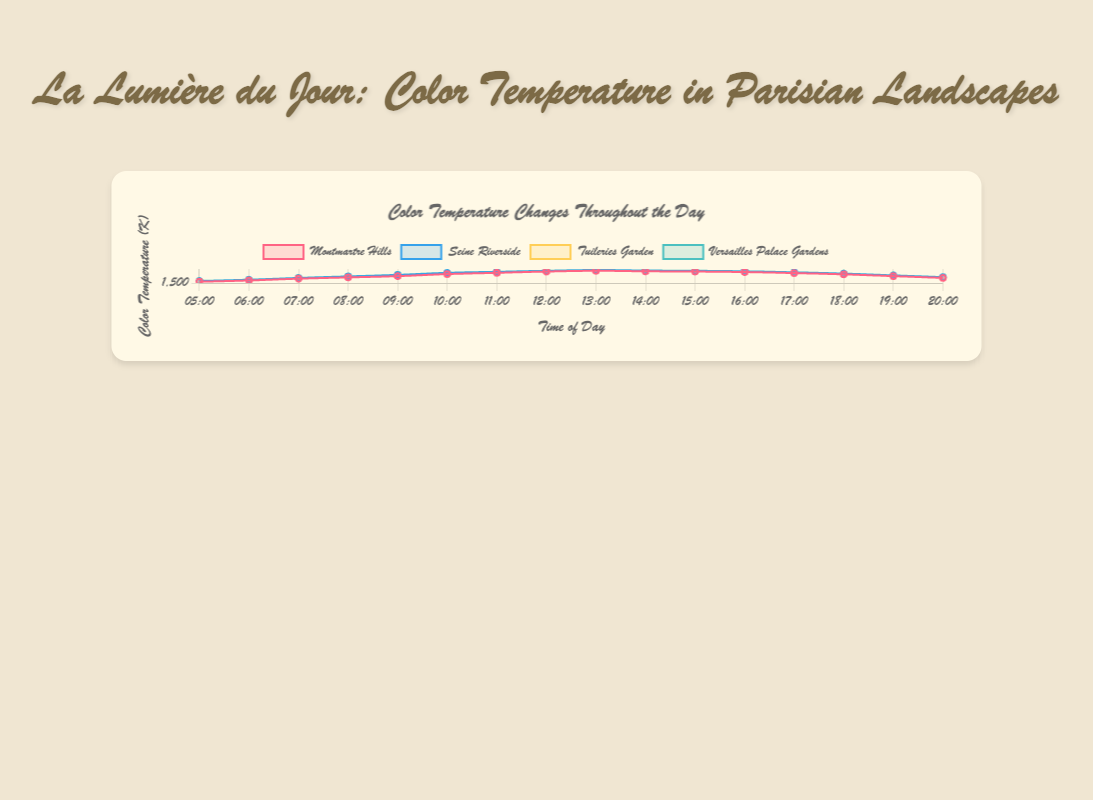What's the highest color temperature recorded in Montmartre Hills? To find the highest color temperature for Montmartre Hills, look at the temperature values across all times. The highest value recorded is 6300K at 13:00.
Answer: 6300K How does the color temperature in Seine Riverside at 10:00 compare to that in Tuileries Garden at the same time? Compare the color temperatures of Seine Riverside and Tuileries Garden at 10:00. For Seine Riverside, the temperature at 10:00 is 5400K, and for Tuileries Garden, it’s 5300K. Seine Riverside’s temperature is slightly higher.
Answer: Seine Riverside is higher What is the average color temperature in Versailles Palace Gardens between 05:00 and 08:00? To compute the average, add the temperatures at 05:00, 06:00, 07:00, and 08:00 and then divide by 4. (2300 + 2800 + 3500 + 4100) / 4 = 12700 / 4 = 3175K
Answer: 3175K At what time does Tuileries Garden have the lowest color temperature? Identify the lowest color temperature value for Tuileries Garden and its corresponding time. The lowest value is 2100K at 05:00.
Answer: 05:00 During which period does Montmartre Hills experience a decrease in color temperature in the afternoon? Look at the values from 12:00 onwards for Montmartre Hills. The temperature decreases from 13:00 (6300K) to 20:00 (3500K).
Answer: 13:00 to 20:00 Which landscape reaches a color temperature of 6000K first, and at what time? Compare the times each landscape reaches 6000K. Montmartre Hills first hits 6000K at 12:00, Seine Riverside at 12:00, Tuileries Garden at 12:00, and Versailles Palace Gardens at 12:00. They all reach it at the same time, 12:00.
Answer: All at 12:00 Is the color temperature change smoother in Seine Riverside or Montmartre Hills from 06:00 to 12:00? Compare the temperature changes from 06:00 to 12:00 for both Seine Riverside and Montmartre Hills. Montmartre Hills changes from 2500K to 6000K (3500K increase). Seine Riverside changes from 2700K to 6200K (3500K increase). Both show a smooth increase but need visual inspection for smoothness. Montmartre Hills has more linear intervals.
Answer: Montmartre Hills How much does the color temperature change in Versailles Palace Gardens from 14:00 to 18:00? Subtract the temperature at 18:00 (5200K) from the temperature at 14:00 (6400K). The change is 6400K - 5200K = 1200K.
Answer: 1200K Which landscape shows the most significant decrease in temperature after 17:00? Compare the temperature drops post-17:00 for each landscape. Each landscape's values indicate a drop, but Versailles Palace Gardens go from 5700K at 17:00 to 3800K at 20:00, the most significant decrease of 1900K.
Answer: Versailles Palace Gardens 